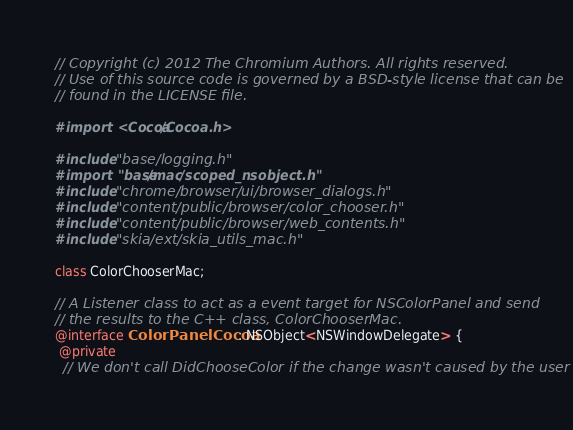Convert code to text. <code><loc_0><loc_0><loc_500><loc_500><_ObjectiveC_>// Copyright (c) 2012 The Chromium Authors. All rights reserved.
// Use of this source code is governed by a BSD-style license that can be
// found in the LICENSE file.

#import <Cocoa/Cocoa.h>

#include "base/logging.h"
#import "base/mac/scoped_nsobject.h"
#include "chrome/browser/ui/browser_dialogs.h"
#include "content/public/browser/color_chooser.h"
#include "content/public/browser/web_contents.h"
#include "skia/ext/skia_utils_mac.h"

class ColorChooserMac;

// A Listener class to act as a event target for NSColorPanel and send
// the results to the C++ class, ColorChooserMac.
@interface ColorPanelCocoa : NSObject<NSWindowDelegate> {
 @private
  // We don't call DidChooseColor if the change wasn't caused by the user</code> 